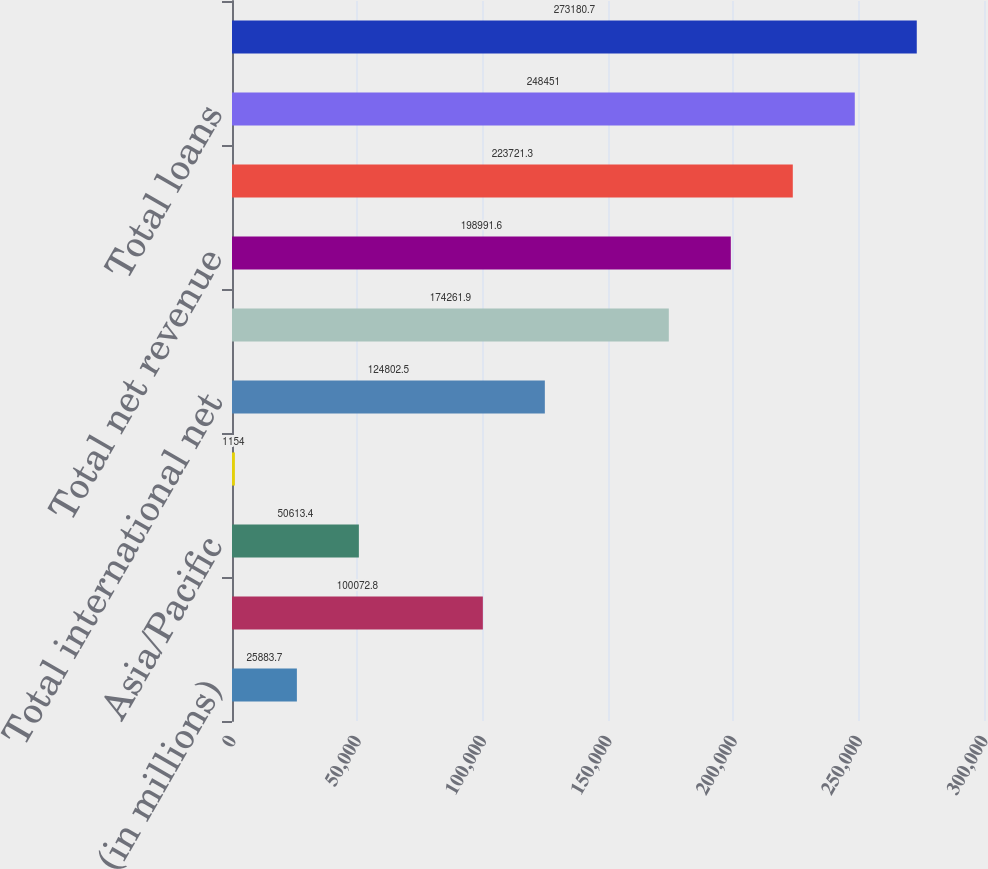<chart> <loc_0><loc_0><loc_500><loc_500><bar_chart><fcel>(in millions)<fcel>Europe/Middle East/Africa<fcel>Asia/Pacific<fcel>Latin America/Caribbean<fcel>Total international net<fcel>North America<fcel>Total net revenue<fcel>Total international loans<fcel>Total loans<fcel>Total international<nl><fcel>25883.7<fcel>100073<fcel>50613.4<fcel>1154<fcel>124802<fcel>174262<fcel>198992<fcel>223721<fcel>248451<fcel>273181<nl></chart> 